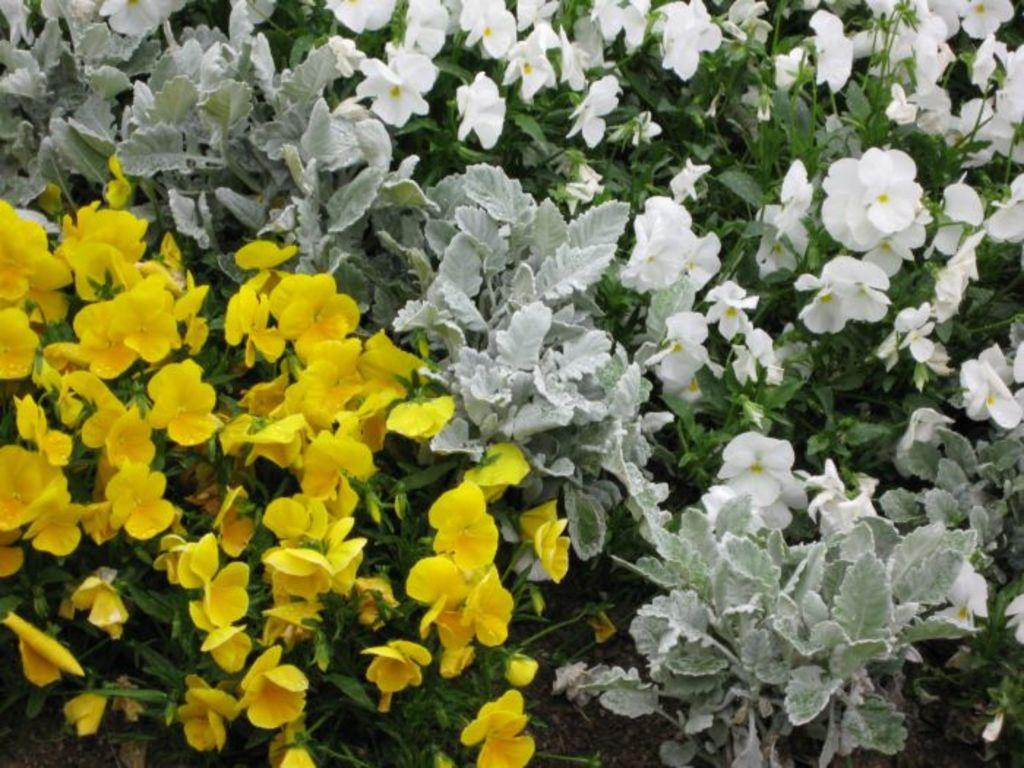What is the main subject of the image? There is a bunch of flowers in the image. What else can be seen in the image besides the flowers? There are leaves in the image. What type of substance is being drained from the flowers in the image? There is no indication of any substance being drained from the flowers in the image. 